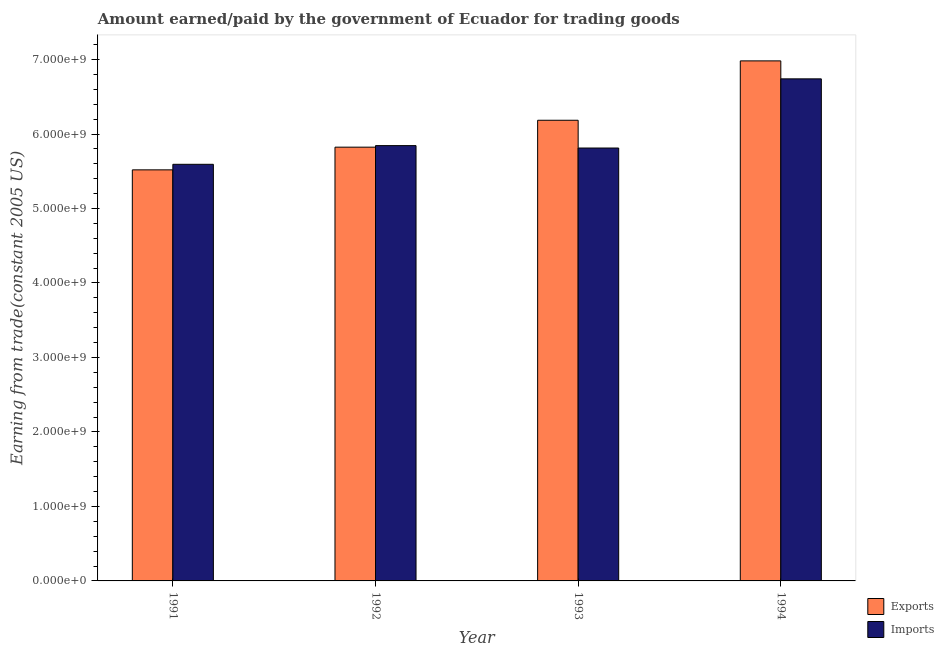Are the number of bars per tick equal to the number of legend labels?
Offer a very short reply. Yes. Are the number of bars on each tick of the X-axis equal?
Give a very brief answer. Yes. What is the label of the 3rd group of bars from the left?
Give a very brief answer. 1993. What is the amount earned from exports in 1991?
Your answer should be compact. 5.52e+09. Across all years, what is the maximum amount paid for imports?
Your response must be concise. 6.74e+09. Across all years, what is the minimum amount paid for imports?
Provide a succinct answer. 5.59e+09. What is the total amount earned from exports in the graph?
Make the answer very short. 2.45e+1. What is the difference between the amount paid for imports in 1991 and that in 1994?
Offer a terse response. -1.15e+09. What is the difference between the amount earned from exports in 1992 and the amount paid for imports in 1994?
Provide a succinct answer. -1.16e+09. What is the average amount paid for imports per year?
Your answer should be compact. 6.00e+09. What is the ratio of the amount paid for imports in 1991 to that in 1993?
Your response must be concise. 0.96. Is the difference between the amount paid for imports in 1992 and 1993 greater than the difference between the amount earned from exports in 1992 and 1993?
Provide a short and direct response. No. What is the difference between the highest and the second highest amount earned from exports?
Your answer should be compact. 7.97e+08. What is the difference between the highest and the lowest amount paid for imports?
Offer a terse response. 1.15e+09. In how many years, is the amount earned from exports greater than the average amount earned from exports taken over all years?
Your response must be concise. 2. Is the sum of the amount earned from exports in 1991 and 1993 greater than the maximum amount paid for imports across all years?
Make the answer very short. Yes. What does the 1st bar from the left in 1991 represents?
Your answer should be very brief. Exports. What does the 2nd bar from the right in 1992 represents?
Keep it short and to the point. Exports. How many bars are there?
Give a very brief answer. 8. Are all the bars in the graph horizontal?
Provide a short and direct response. No. What is the difference between two consecutive major ticks on the Y-axis?
Your response must be concise. 1.00e+09. Where does the legend appear in the graph?
Offer a terse response. Bottom right. What is the title of the graph?
Provide a short and direct response. Amount earned/paid by the government of Ecuador for trading goods. What is the label or title of the X-axis?
Give a very brief answer. Year. What is the label or title of the Y-axis?
Your answer should be very brief. Earning from trade(constant 2005 US). What is the Earning from trade(constant 2005 US) in Exports in 1991?
Provide a short and direct response. 5.52e+09. What is the Earning from trade(constant 2005 US) in Imports in 1991?
Provide a succinct answer. 5.59e+09. What is the Earning from trade(constant 2005 US) in Exports in 1992?
Make the answer very short. 5.82e+09. What is the Earning from trade(constant 2005 US) of Imports in 1992?
Provide a short and direct response. 5.84e+09. What is the Earning from trade(constant 2005 US) in Exports in 1993?
Provide a succinct answer. 6.18e+09. What is the Earning from trade(constant 2005 US) of Imports in 1993?
Provide a short and direct response. 5.81e+09. What is the Earning from trade(constant 2005 US) in Exports in 1994?
Ensure brevity in your answer.  6.98e+09. What is the Earning from trade(constant 2005 US) of Imports in 1994?
Ensure brevity in your answer.  6.74e+09. Across all years, what is the maximum Earning from trade(constant 2005 US) in Exports?
Your answer should be compact. 6.98e+09. Across all years, what is the maximum Earning from trade(constant 2005 US) in Imports?
Provide a succinct answer. 6.74e+09. Across all years, what is the minimum Earning from trade(constant 2005 US) of Exports?
Provide a short and direct response. 5.52e+09. Across all years, what is the minimum Earning from trade(constant 2005 US) of Imports?
Provide a short and direct response. 5.59e+09. What is the total Earning from trade(constant 2005 US) in Exports in the graph?
Your response must be concise. 2.45e+1. What is the total Earning from trade(constant 2005 US) in Imports in the graph?
Offer a very short reply. 2.40e+1. What is the difference between the Earning from trade(constant 2005 US) in Exports in 1991 and that in 1992?
Provide a succinct answer. -3.04e+08. What is the difference between the Earning from trade(constant 2005 US) in Imports in 1991 and that in 1992?
Provide a short and direct response. -2.51e+08. What is the difference between the Earning from trade(constant 2005 US) of Exports in 1991 and that in 1993?
Your answer should be very brief. -6.66e+08. What is the difference between the Earning from trade(constant 2005 US) in Imports in 1991 and that in 1993?
Keep it short and to the point. -2.19e+08. What is the difference between the Earning from trade(constant 2005 US) in Exports in 1991 and that in 1994?
Provide a short and direct response. -1.46e+09. What is the difference between the Earning from trade(constant 2005 US) in Imports in 1991 and that in 1994?
Provide a short and direct response. -1.15e+09. What is the difference between the Earning from trade(constant 2005 US) in Exports in 1992 and that in 1993?
Provide a succinct answer. -3.61e+08. What is the difference between the Earning from trade(constant 2005 US) of Imports in 1992 and that in 1993?
Make the answer very short. 3.22e+07. What is the difference between the Earning from trade(constant 2005 US) of Exports in 1992 and that in 1994?
Offer a very short reply. -1.16e+09. What is the difference between the Earning from trade(constant 2005 US) of Imports in 1992 and that in 1994?
Provide a short and direct response. -8.96e+08. What is the difference between the Earning from trade(constant 2005 US) of Exports in 1993 and that in 1994?
Your answer should be compact. -7.97e+08. What is the difference between the Earning from trade(constant 2005 US) in Imports in 1993 and that in 1994?
Make the answer very short. -9.29e+08. What is the difference between the Earning from trade(constant 2005 US) of Exports in 1991 and the Earning from trade(constant 2005 US) of Imports in 1992?
Keep it short and to the point. -3.25e+08. What is the difference between the Earning from trade(constant 2005 US) in Exports in 1991 and the Earning from trade(constant 2005 US) in Imports in 1993?
Offer a terse response. -2.93e+08. What is the difference between the Earning from trade(constant 2005 US) in Exports in 1991 and the Earning from trade(constant 2005 US) in Imports in 1994?
Ensure brevity in your answer.  -1.22e+09. What is the difference between the Earning from trade(constant 2005 US) in Exports in 1992 and the Earning from trade(constant 2005 US) in Imports in 1993?
Ensure brevity in your answer.  1.14e+07. What is the difference between the Earning from trade(constant 2005 US) in Exports in 1992 and the Earning from trade(constant 2005 US) in Imports in 1994?
Your answer should be compact. -9.17e+08. What is the difference between the Earning from trade(constant 2005 US) of Exports in 1993 and the Earning from trade(constant 2005 US) of Imports in 1994?
Offer a very short reply. -5.56e+08. What is the average Earning from trade(constant 2005 US) in Exports per year?
Provide a short and direct response. 6.13e+09. What is the average Earning from trade(constant 2005 US) of Imports per year?
Offer a very short reply. 6.00e+09. In the year 1991, what is the difference between the Earning from trade(constant 2005 US) of Exports and Earning from trade(constant 2005 US) of Imports?
Offer a terse response. -7.43e+07. In the year 1992, what is the difference between the Earning from trade(constant 2005 US) of Exports and Earning from trade(constant 2005 US) of Imports?
Provide a short and direct response. -2.08e+07. In the year 1993, what is the difference between the Earning from trade(constant 2005 US) of Exports and Earning from trade(constant 2005 US) of Imports?
Provide a short and direct response. 3.73e+08. In the year 1994, what is the difference between the Earning from trade(constant 2005 US) of Exports and Earning from trade(constant 2005 US) of Imports?
Provide a succinct answer. 2.41e+08. What is the ratio of the Earning from trade(constant 2005 US) in Exports in 1991 to that in 1992?
Keep it short and to the point. 0.95. What is the ratio of the Earning from trade(constant 2005 US) of Imports in 1991 to that in 1992?
Your response must be concise. 0.96. What is the ratio of the Earning from trade(constant 2005 US) in Exports in 1991 to that in 1993?
Your answer should be very brief. 0.89. What is the ratio of the Earning from trade(constant 2005 US) in Imports in 1991 to that in 1993?
Provide a succinct answer. 0.96. What is the ratio of the Earning from trade(constant 2005 US) in Exports in 1991 to that in 1994?
Offer a very short reply. 0.79. What is the ratio of the Earning from trade(constant 2005 US) of Imports in 1991 to that in 1994?
Keep it short and to the point. 0.83. What is the ratio of the Earning from trade(constant 2005 US) in Exports in 1992 to that in 1993?
Offer a terse response. 0.94. What is the ratio of the Earning from trade(constant 2005 US) in Imports in 1992 to that in 1993?
Provide a short and direct response. 1.01. What is the ratio of the Earning from trade(constant 2005 US) in Exports in 1992 to that in 1994?
Provide a succinct answer. 0.83. What is the ratio of the Earning from trade(constant 2005 US) of Imports in 1992 to that in 1994?
Provide a succinct answer. 0.87. What is the ratio of the Earning from trade(constant 2005 US) of Exports in 1993 to that in 1994?
Ensure brevity in your answer.  0.89. What is the ratio of the Earning from trade(constant 2005 US) in Imports in 1993 to that in 1994?
Your response must be concise. 0.86. What is the difference between the highest and the second highest Earning from trade(constant 2005 US) in Exports?
Make the answer very short. 7.97e+08. What is the difference between the highest and the second highest Earning from trade(constant 2005 US) of Imports?
Offer a very short reply. 8.96e+08. What is the difference between the highest and the lowest Earning from trade(constant 2005 US) in Exports?
Ensure brevity in your answer.  1.46e+09. What is the difference between the highest and the lowest Earning from trade(constant 2005 US) of Imports?
Give a very brief answer. 1.15e+09. 